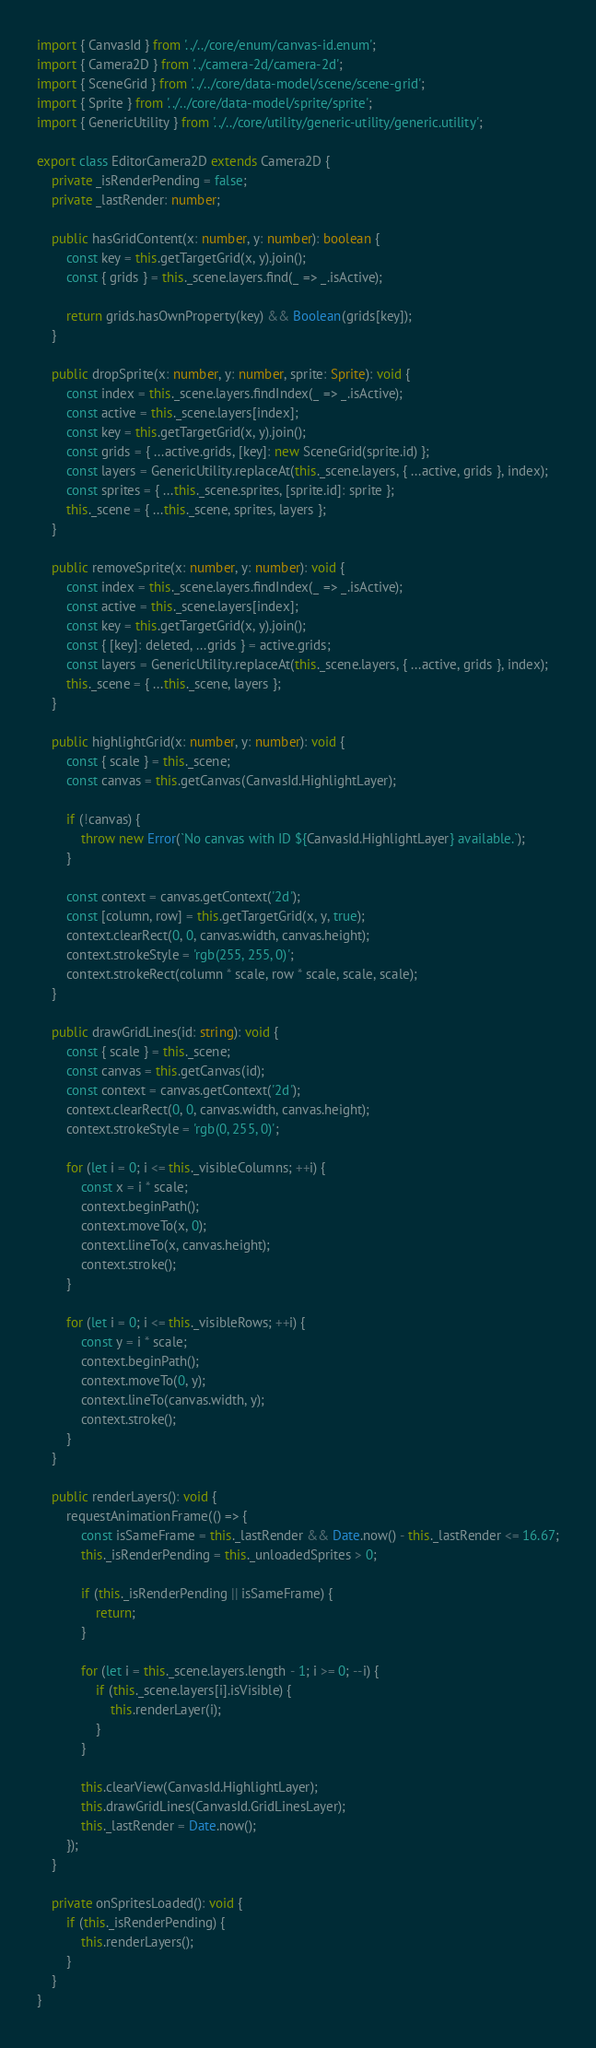Convert code to text. <code><loc_0><loc_0><loc_500><loc_500><_TypeScript_>import { CanvasId } from '../../core/enum/canvas-id.enum';
import { Camera2D } from '../camera-2d/camera-2d';
import { SceneGrid } from '../../core/data-model/scene/scene-grid';
import { Sprite } from '../../core/data-model/sprite/sprite';
import { GenericUtility } from '../../core/utility/generic-utility/generic.utility';

export class EditorCamera2D extends Camera2D {
    private _isRenderPending = false;
    private _lastRender: number;

    public hasGridContent(x: number, y: number): boolean {
        const key = this.getTargetGrid(x, y).join();
        const { grids } = this._scene.layers.find(_ => _.isActive);

        return grids.hasOwnProperty(key) && Boolean(grids[key]);
    }

    public dropSprite(x: number, y: number, sprite: Sprite): void {
        const index = this._scene.layers.findIndex(_ => _.isActive);
        const active = this._scene.layers[index];
        const key = this.getTargetGrid(x, y).join();
        const grids = { ...active.grids, [key]: new SceneGrid(sprite.id) };
        const layers = GenericUtility.replaceAt(this._scene.layers, { ...active, grids }, index);
        const sprites = { ...this._scene.sprites, [sprite.id]: sprite };
        this._scene = { ...this._scene, sprites, layers };
    }

    public removeSprite(x: number, y: number): void {
        const index = this._scene.layers.findIndex(_ => _.isActive);
        const active = this._scene.layers[index];
        const key = this.getTargetGrid(x, y).join();
        const { [key]: deleted, ...grids } = active.grids;
        const layers = GenericUtility.replaceAt(this._scene.layers, { ...active, grids }, index);
        this._scene = { ...this._scene, layers };
    }

    public highlightGrid(x: number, y: number): void {
        const { scale } = this._scene;
        const canvas = this.getCanvas(CanvasId.HighlightLayer);

        if (!canvas) {
            throw new Error(`No canvas with ID ${CanvasId.HighlightLayer} available.`);
        }

        const context = canvas.getContext('2d');
        const [column, row] = this.getTargetGrid(x, y, true);
        context.clearRect(0, 0, canvas.width, canvas.height);
        context.strokeStyle = 'rgb(255, 255, 0)';
        context.strokeRect(column * scale, row * scale, scale, scale);
    }

    public drawGridLines(id: string): void {
        const { scale } = this._scene;
        const canvas = this.getCanvas(id);
        const context = canvas.getContext('2d');
        context.clearRect(0, 0, canvas.width, canvas.height);
        context.strokeStyle = 'rgb(0, 255, 0)';

        for (let i = 0; i <= this._visibleColumns; ++i) {
            const x = i * scale;
            context.beginPath();
            context.moveTo(x, 0);
            context.lineTo(x, canvas.height);
            context.stroke();
        }

        for (let i = 0; i <= this._visibleRows; ++i) {
            const y = i * scale;
            context.beginPath();
            context.moveTo(0, y);
            context.lineTo(canvas.width, y);
            context.stroke();
        }
    }

    public renderLayers(): void {
        requestAnimationFrame(() => {
            const isSameFrame = this._lastRender && Date.now() - this._lastRender <= 16.67;
            this._isRenderPending = this._unloadedSprites > 0;

            if (this._isRenderPending || isSameFrame) {
                return;
            }

            for (let i = this._scene.layers.length - 1; i >= 0; --i) {
                if (this._scene.layers[i].isVisible) {
                    this.renderLayer(i);
                }
            }

            this.clearView(CanvasId.HighlightLayer);
            this.drawGridLines(CanvasId.GridLinesLayer);
            this._lastRender = Date.now();
        });
    }

    private onSpritesLoaded(): void {
        if (this._isRenderPending) {
            this.renderLayers();
        }
    }
}
</code> 